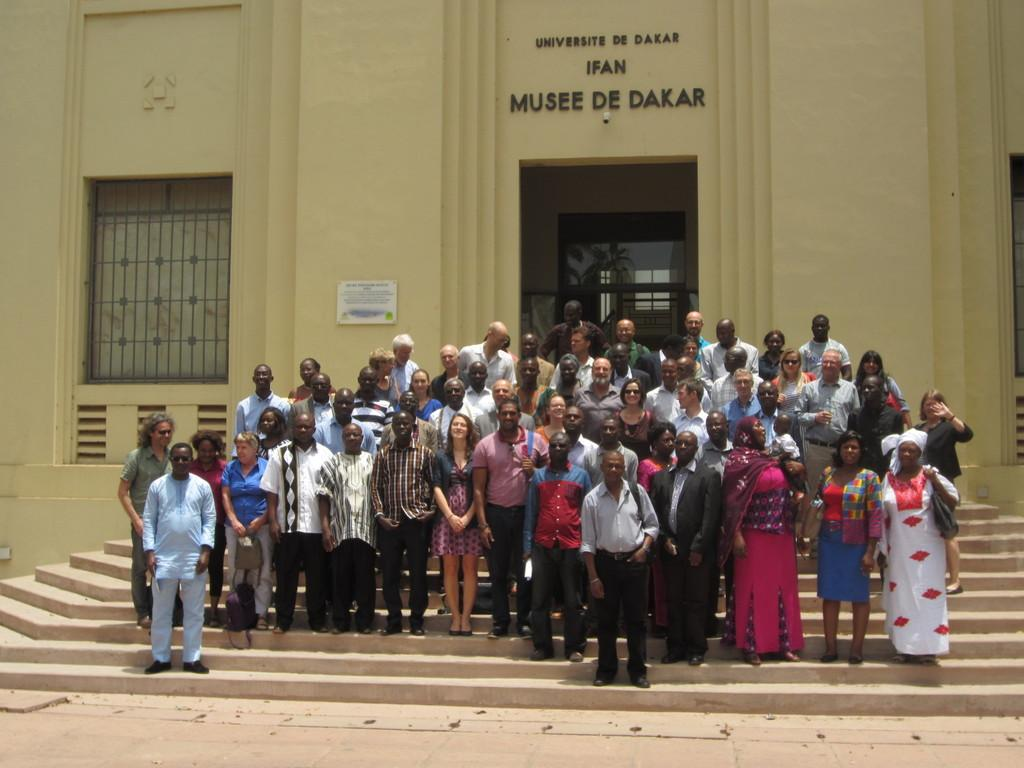What are the people in the image doing? The people in the image are standing on the stairs. What can be seen in the background of the image? There is a building in the background. What object is present in the image with the people? There is a board in the image. What is written on the wall of the building? There is text on the wall of the building. What type of toothpaste is being used by the laborer in the image? There is no laborer or toothpaste present in the image. What is the tray used for in the image? There is no tray present in the image. 